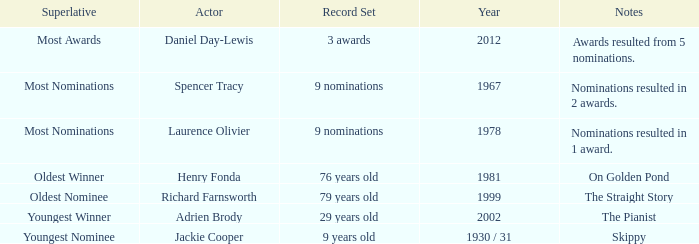Who was the winning actor in 1978? Laurence Olivier. Can you give me this table as a dict? {'header': ['Superlative', 'Actor', 'Record Set', 'Year', 'Notes'], 'rows': [['Most Awards', 'Daniel Day-Lewis', '3 awards', '2012', 'Awards resulted from 5 nominations.'], ['Most Nominations', 'Spencer Tracy', '9 nominations', '1967', 'Nominations resulted in 2 awards.'], ['Most Nominations', 'Laurence Olivier', '9 nominations', '1978', 'Nominations resulted in 1 award.'], ['Oldest Winner', 'Henry Fonda', '76 years old', '1981', 'On Golden Pond'], ['Oldest Nominee', 'Richard Farnsworth', '79 years old', '1999', 'The Straight Story'], ['Youngest Winner', 'Adrien Brody', '29 years old', '2002', 'The Pianist'], ['Youngest Nominee', 'Jackie Cooper', '9 years old', '1930 / 31', 'Skippy']]} 